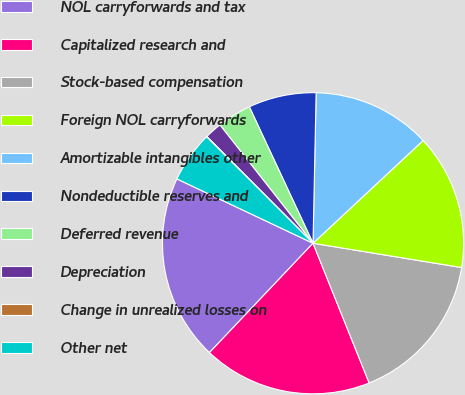<chart> <loc_0><loc_0><loc_500><loc_500><pie_chart><fcel>NOL carryforwards and tax<fcel>Capitalized research and<fcel>Stock-based compensation<fcel>Foreign NOL carryforwards<fcel>Amortizable intangibles other<fcel>Nondeductible reserves and<fcel>Deferred revenue<fcel>Depreciation<fcel>Change in unrealized losses on<fcel>Other net<nl><fcel>19.96%<fcel>18.15%<fcel>16.34%<fcel>14.53%<fcel>12.72%<fcel>7.28%<fcel>3.66%<fcel>1.85%<fcel>0.04%<fcel>5.47%<nl></chart> 